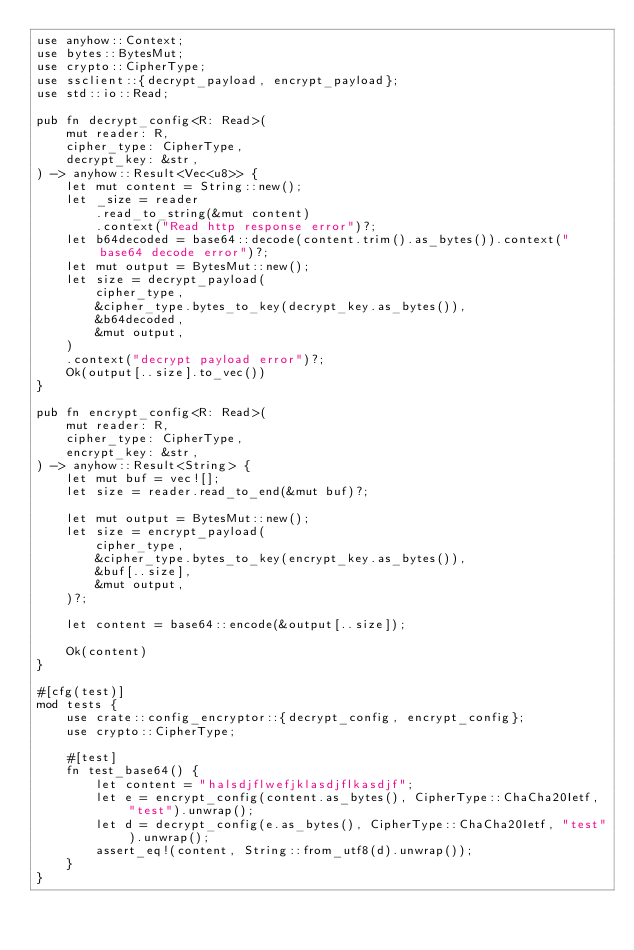Convert code to text. <code><loc_0><loc_0><loc_500><loc_500><_Rust_>use anyhow::Context;
use bytes::BytesMut;
use crypto::CipherType;
use ssclient::{decrypt_payload, encrypt_payload};
use std::io::Read;

pub fn decrypt_config<R: Read>(
    mut reader: R,
    cipher_type: CipherType,
    decrypt_key: &str,
) -> anyhow::Result<Vec<u8>> {
    let mut content = String::new();
    let _size = reader
        .read_to_string(&mut content)
        .context("Read http response error")?;
    let b64decoded = base64::decode(content.trim().as_bytes()).context("base64 decode error")?;
    let mut output = BytesMut::new();
    let size = decrypt_payload(
        cipher_type,
        &cipher_type.bytes_to_key(decrypt_key.as_bytes()),
        &b64decoded,
        &mut output,
    )
    .context("decrypt payload error")?;
    Ok(output[..size].to_vec())
}

pub fn encrypt_config<R: Read>(
    mut reader: R,
    cipher_type: CipherType,
    encrypt_key: &str,
) -> anyhow::Result<String> {
    let mut buf = vec![];
    let size = reader.read_to_end(&mut buf)?;

    let mut output = BytesMut::new();
    let size = encrypt_payload(
        cipher_type,
        &cipher_type.bytes_to_key(encrypt_key.as_bytes()),
        &buf[..size],
        &mut output,
    )?;

    let content = base64::encode(&output[..size]);

    Ok(content)
}

#[cfg(test)]
mod tests {
    use crate::config_encryptor::{decrypt_config, encrypt_config};
    use crypto::CipherType;

    #[test]
    fn test_base64() {
        let content = "halsdjflwefjklasdjflkasdjf";
        let e = encrypt_config(content.as_bytes(), CipherType::ChaCha20Ietf, "test").unwrap();
        let d = decrypt_config(e.as_bytes(), CipherType::ChaCha20Ietf, "test").unwrap();
        assert_eq!(content, String::from_utf8(d).unwrap());
    }
}
</code> 